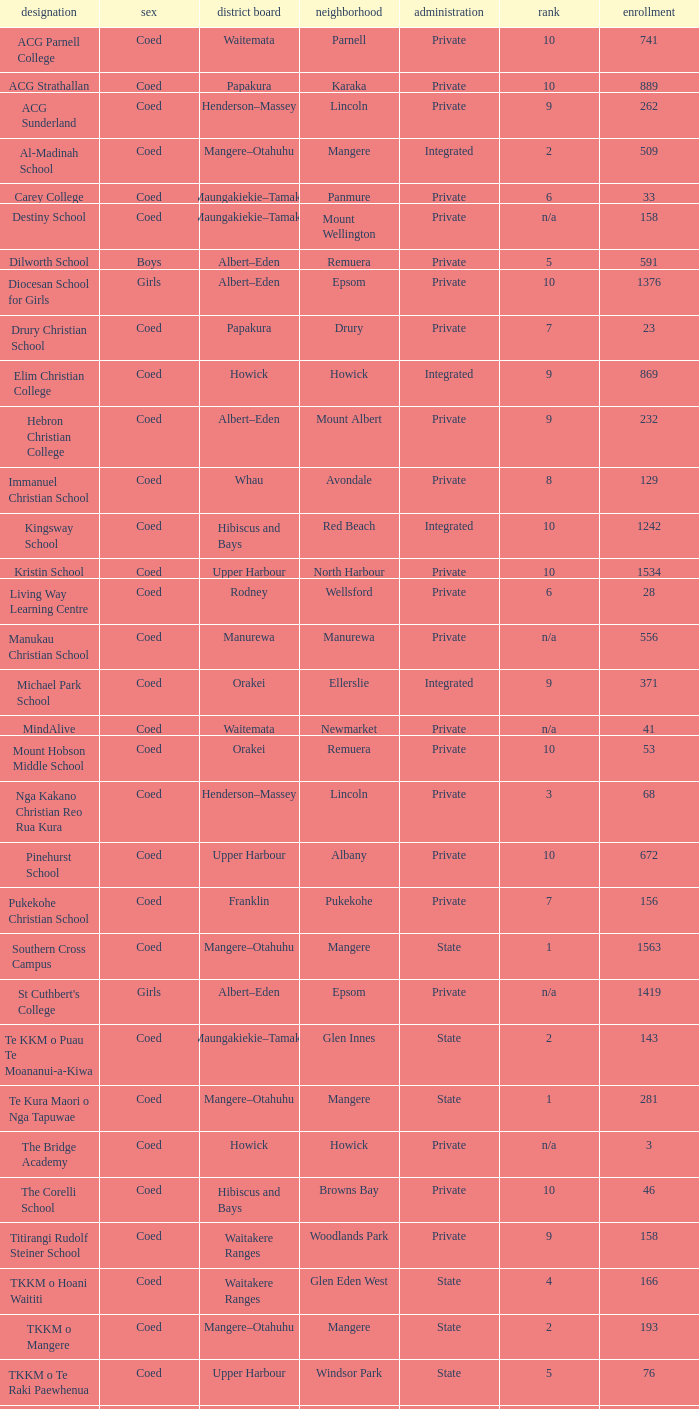What gender has a local board of albert–eden with a roll of more than 232 and Decile of 5? Boys. 